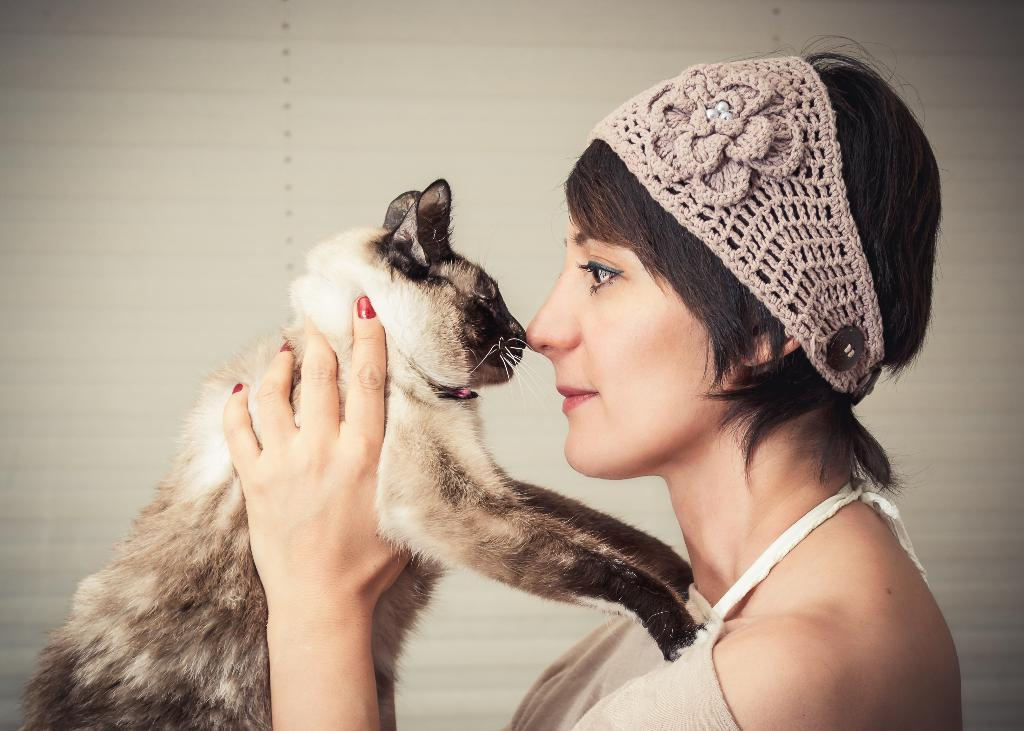Who or what is the main subject in the image? There is a person in the image. What is the person holding in the image? The person is holding a cat. What type of crime is being committed in the image? There is no crime being committed in the image; it features a person holding a cat. How many times has the person walked the cat in the image? There is no indication of the person walking the cat in the image, as the cat is being held. 